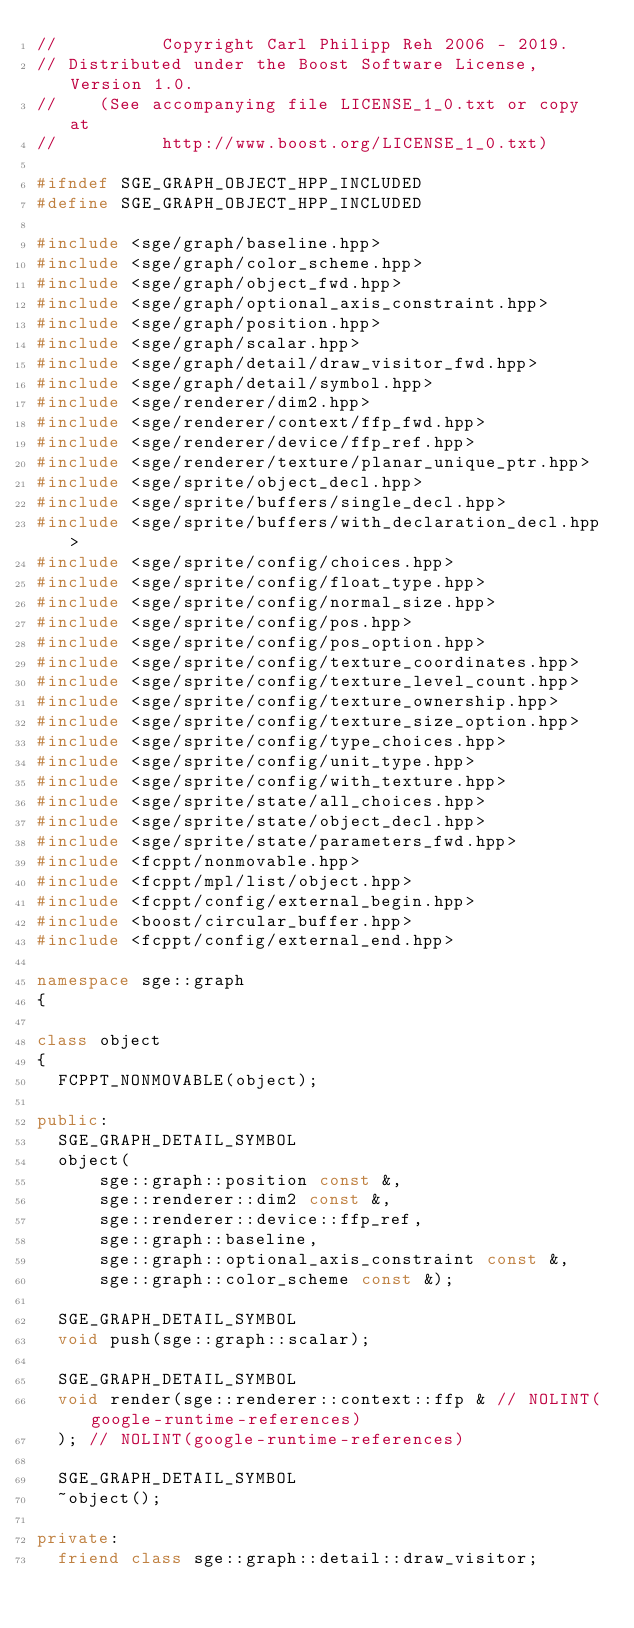<code> <loc_0><loc_0><loc_500><loc_500><_C++_>//          Copyright Carl Philipp Reh 2006 - 2019.
// Distributed under the Boost Software License, Version 1.0.
//    (See accompanying file LICENSE_1_0.txt or copy at
//          http://www.boost.org/LICENSE_1_0.txt)

#ifndef SGE_GRAPH_OBJECT_HPP_INCLUDED
#define SGE_GRAPH_OBJECT_HPP_INCLUDED

#include <sge/graph/baseline.hpp>
#include <sge/graph/color_scheme.hpp>
#include <sge/graph/object_fwd.hpp>
#include <sge/graph/optional_axis_constraint.hpp>
#include <sge/graph/position.hpp>
#include <sge/graph/scalar.hpp>
#include <sge/graph/detail/draw_visitor_fwd.hpp>
#include <sge/graph/detail/symbol.hpp>
#include <sge/renderer/dim2.hpp>
#include <sge/renderer/context/ffp_fwd.hpp>
#include <sge/renderer/device/ffp_ref.hpp>
#include <sge/renderer/texture/planar_unique_ptr.hpp>
#include <sge/sprite/object_decl.hpp>
#include <sge/sprite/buffers/single_decl.hpp>
#include <sge/sprite/buffers/with_declaration_decl.hpp>
#include <sge/sprite/config/choices.hpp>
#include <sge/sprite/config/float_type.hpp>
#include <sge/sprite/config/normal_size.hpp>
#include <sge/sprite/config/pos.hpp>
#include <sge/sprite/config/pos_option.hpp>
#include <sge/sprite/config/texture_coordinates.hpp>
#include <sge/sprite/config/texture_level_count.hpp>
#include <sge/sprite/config/texture_ownership.hpp>
#include <sge/sprite/config/texture_size_option.hpp>
#include <sge/sprite/config/type_choices.hpp>
#include <sge/sprite/config/unit_type.hpp>
#include <sge/sprite/config/with_texture.hpp>
#include <sge/sprite/state/all_choices.hpp>
#include <sge/sprite/state/object_decl.hpp>
#include <sge/sprite/state/parameters_fwd.hpp>
#include <fcppt/nonmovable.hpp>
#include <fcppt/mpl/list/object.hpp>
#include <fcppt/config/external_begin.hpp>
#include <boost/circular_buffer.hpp>
#include <fcppt/config/external_end.hpp>

namespace sge::graph
{

class object
{
  FCPPT_NONMOVABLE(object);

public:
  SGE_GRAPH_DETAIL_SYMBOL
  object(
      sge::graph::position const &,
      sge::renderer::dim2 const &,
      sge::renderer::device::ffp_ref,
      sge::graph::baseline,
      sge::graph::optional_axis_constraint const &,
      sge::graph::color_scheme const &);

  SGE_GRAPH_DETAIL_SYMBOL
  void push(sge::graph::scalar);

  SGE_GRAPH_DETAIL_SYMBOL
  void render(sge::renderer::context::ffp & // NOLINT(google-runtime-references)
  ); // NOLINT(google-runtime-references)

  SGE_GRAPH_DETAIL_SYMBOL
  ~object();

private:
  friend class sge::graph::detail::draw_visitor;
</code> 